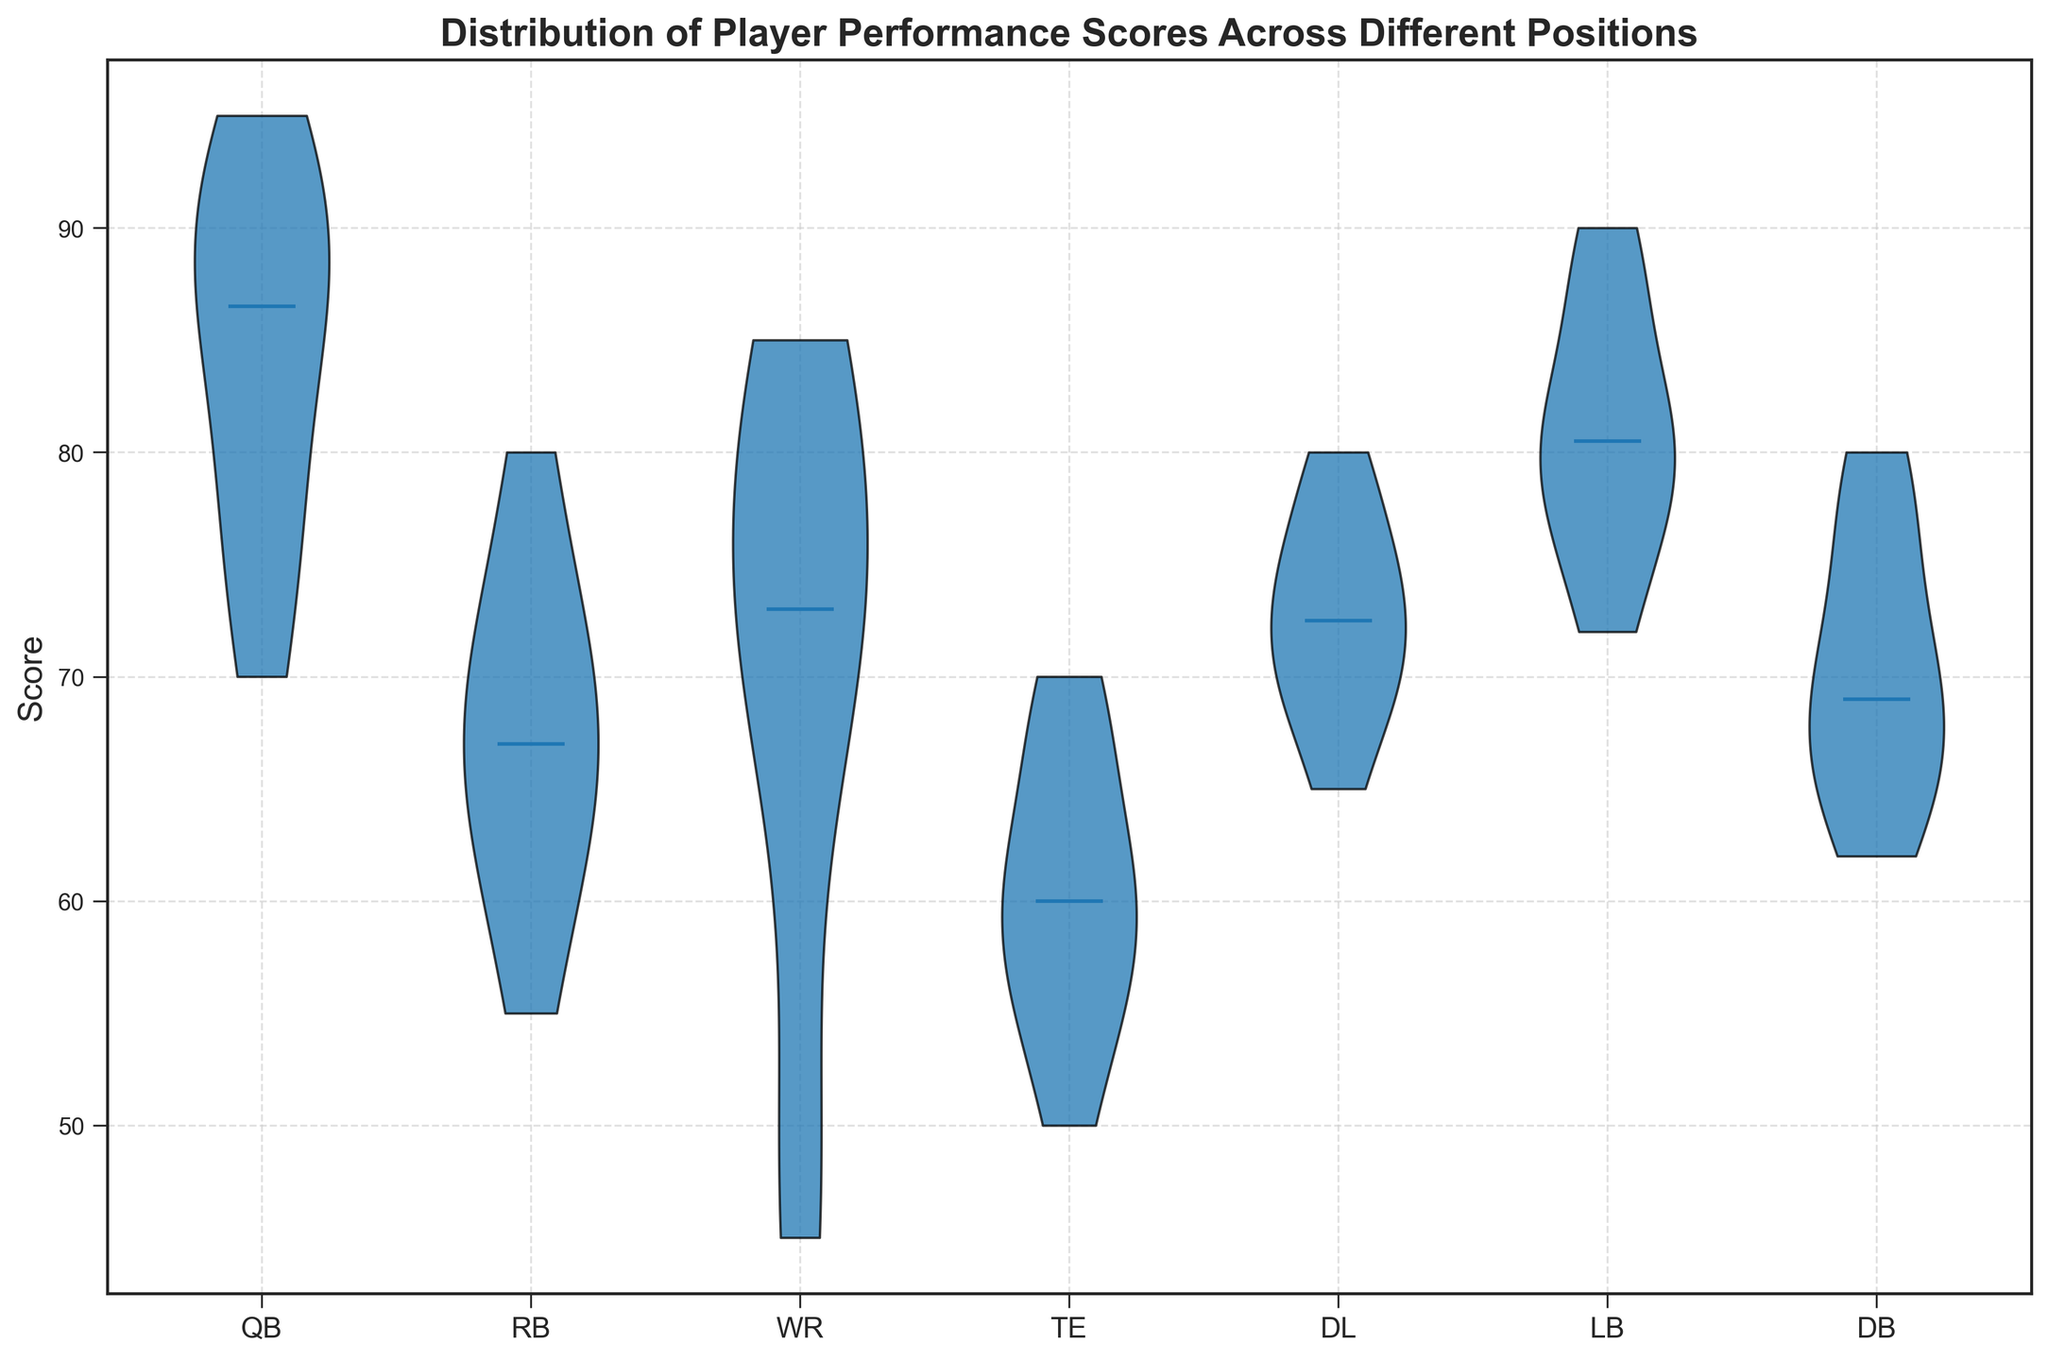What is the median score for QBs? Observe the violin plot for the QB position and locate the horizontal line that indicates the median.
Answer: 88 Which position has the widest range of scores? Compare the lengths of the violins for all positions. The position with the widest violin represents the widest range of scores.
Answer: QB Are the median scores higher for QBs or RBs? Compare the horizontal lines indicating the median scores in the violins for QBs and RBs.
Answer: QBs Which position has the highest median score? Look for the horizontal line indicating the median score that is the highest compared to other positions.
Answer: QB How does the distribution of scores for WRs compare to TEs? Compare the shape of the violins for WRs and TEs. Assess factors like the median, the spread of scores, and whether the distributions are wide or narrow.
Answer: WRs have a wider and higher median distribution than TEs Do QBs have more variability in scores compared to DLs? Compare the spread of scores in the violins for QBs and DLs by looking at the overall width and range of the violins.
Answer: Yes, QBs have more variability Which position shows the lowest scores more frequently, RBs or DBs? Look at the lower part of the violins for the RB and DB positions to see which one extends further down, indicating more lower scores.
Answer: RBs What's the interquartile range (IQR) for QBs' scores? To find the IQR, identify the scores at the 25th and 75th percentiles within the QB violin. As the figure typically does not provide percentile marks within violins, assume general data characteristics.
Answer: Approx. 75 to 90 Between LBs and DBs, which has less spread in their distribution of scores? Compare the overall width and spread of the violins for LBs and DBs. The position with a narrower violin has less spread.
Answer: DBs How do the median scores for offensive positions (QB, RB, WR, TE) compare to defensive positions (DL, LB, DB)? Locate the medians for all offensive and defensive positions from their respective violins and compare them directly.
Answer: Offense generally has higher medians 